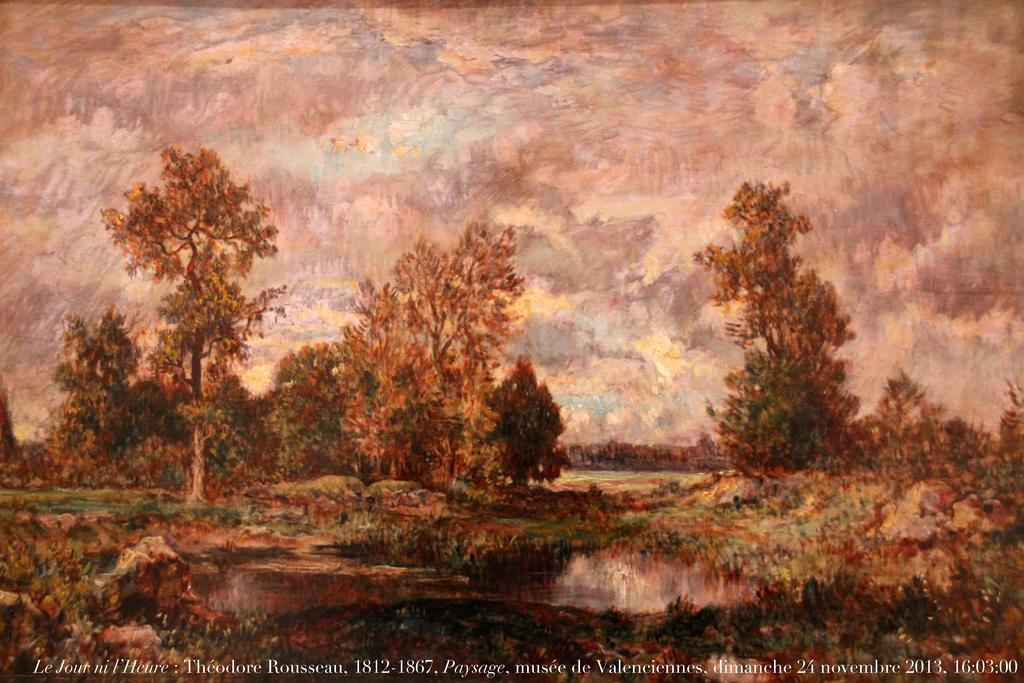Please provide a concise description of this image. In this image we can see a poster. On this poster we can see ground, trees, and sky with clouds. At the bottom of the image we can see something is written on it. 